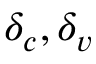<formula> <loc_0><loc_0><loc_500><loc_500>\delta _ { c } , \delta _ { v }</formula> 